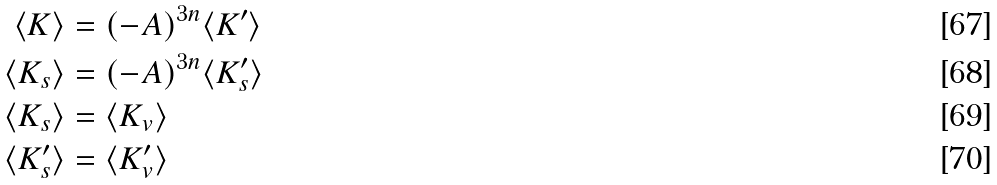<formula> <loc_0><loc_0><loc_500><loc_500>\langle K \rangle & = ( - A ) ^ { 3 n } \langle K ^ { \prime } \rangle \\ \langle K _ { s } \rangle & = ( - A ) ^ { 3 n } \langle K ^ { \prime } _ { s } \rangle \\ \langle K _ { s } \rangle & = \langle K _ { v } \rangle \\ \langle K ^ { \prime } _ { s } \rangle & = \langle K ^ { \prime } _ { v } \rangle</formula> 